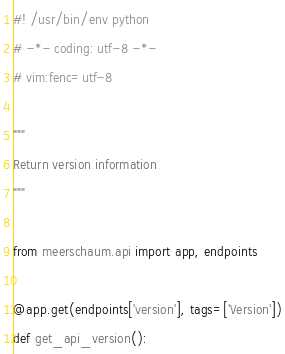<code> <loc_0><loc_0><loc_500><loc_500><_Python_>#! /usr/bin/env python
# -*- coding: utf-8 -*-
# vim:fenc=utf-8

"""
Return version information
"""

from meerschaum.api import app, endpoints

@app.get(endpoints['version'], tags=['Version'])
def get_api_version():</code> 